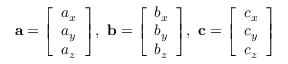<formula> <loc_0><loc_0><loc_500><loc_500>a = { \left [ \begin{array} { l } { a _ { x } } \\ { a _ { y } } \\ { a _ { z } } \end{array} \right ] } , \ b = { \left [ \begin{array} { l } { b _ { x } } \\ { b _ { y } } \\ { b _ { z } } \end{array} \right ] } , \ c = { \left [ \begin{array} { l } { c _ { x } } \\ { c _ { y } } \\ { c _ { z } } \end{array} \right ] }</formula> 